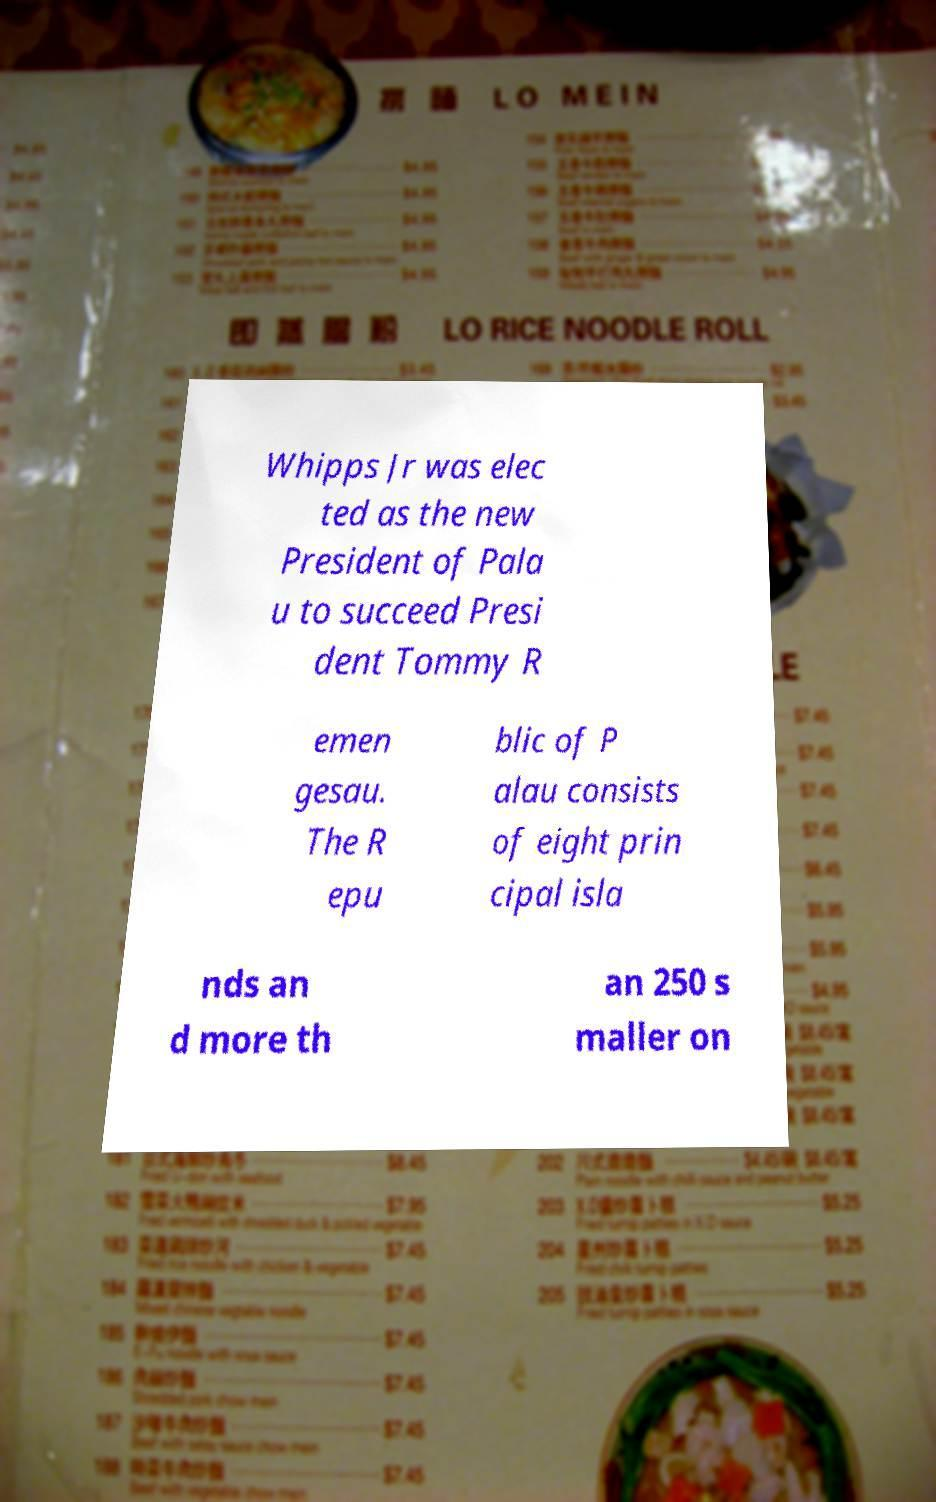Can you read and provide the text displayed in the image?This photo seems to have some interesting text. Can you extract and type it out for me? Whipps Jr was elec ted as the new President of Pala u to succeed Presi dent Tommy R emen gesau. The R epu blic of P alau consists of eight prin cipal isla nds an d more th an 250 s maller on 